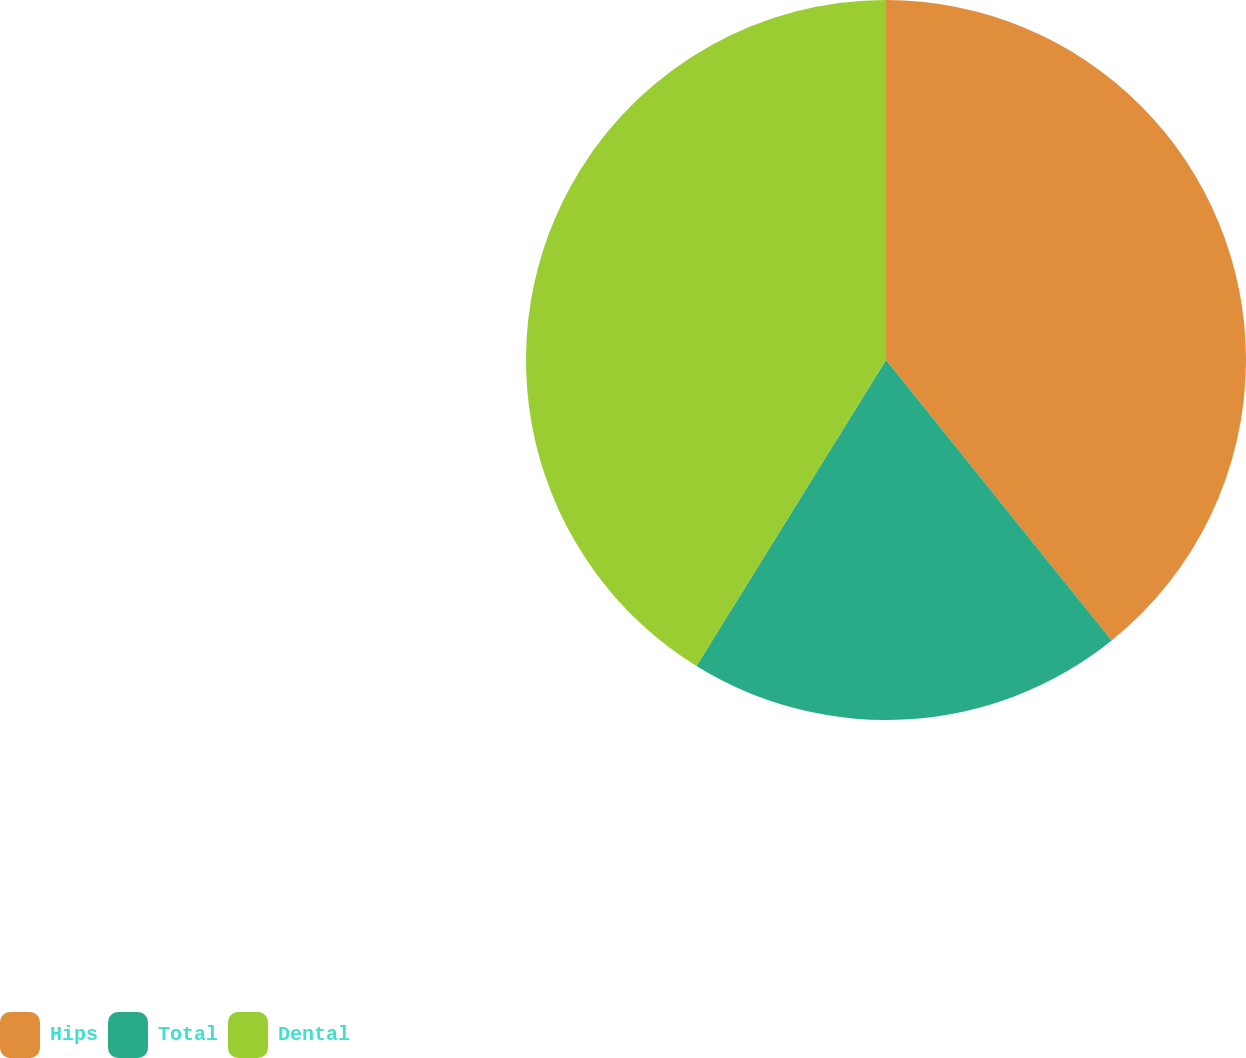Convert chart to OTSL. <chart><loc_0><loc_0><loc_500><loc_500><pie_chart><fcel>Hips<fcel>Total<fcel>Dental<nl><fcel>39.22%<fcel>19.61%<fcel>41.18%<nl></chart> 